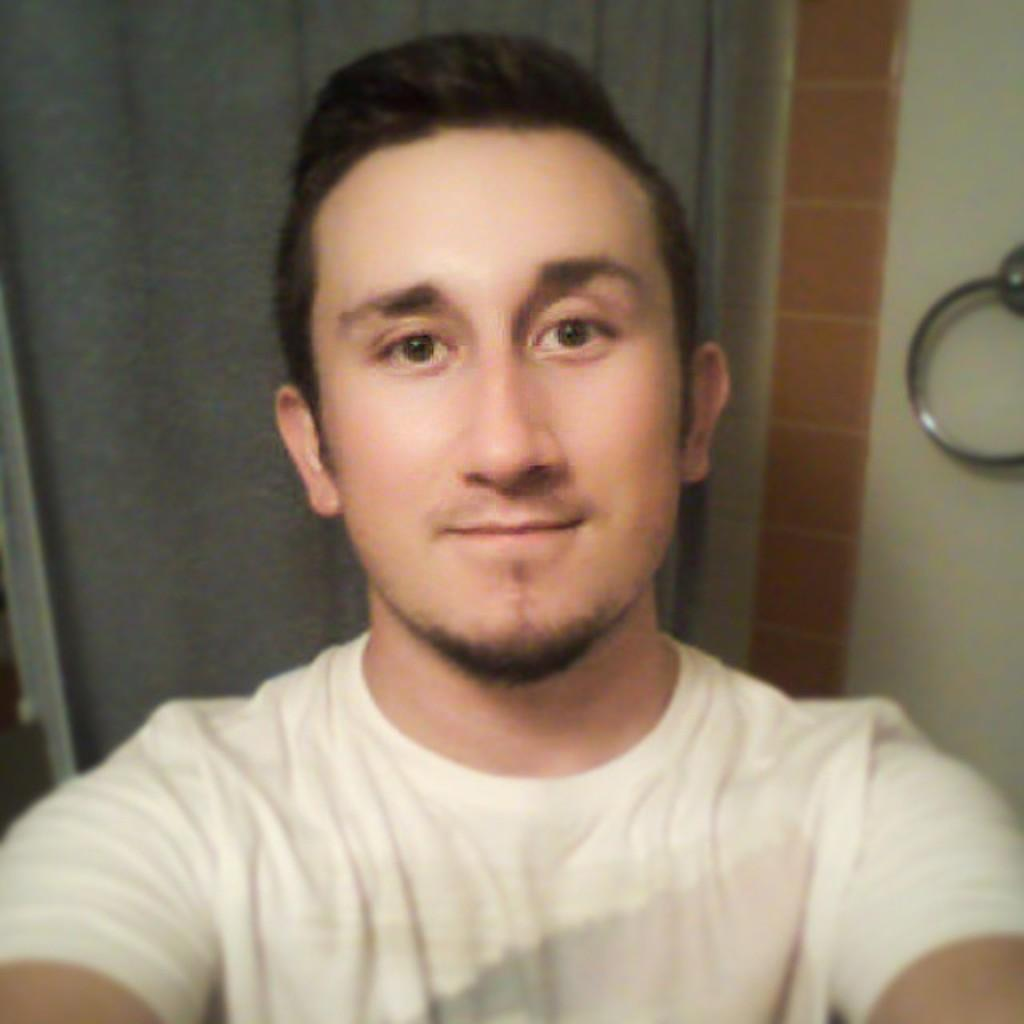Who is present in the image? There is a man in the image. What is the man's facial expression? The man is smiling. What is the man wearing in the image? The man is wearing a white T-shirt. What can be seen attached to the wall in the image? There is a hanger attached to the wall in the image. What type of window treatment is present in the image? There is a curtain hanging in the image. What year is depicted in the image? The image does not depict a specific year; it is a photograph of a man, a hanger, and a curtain. Can you see any fog in the image? There is no fog present in the image. 